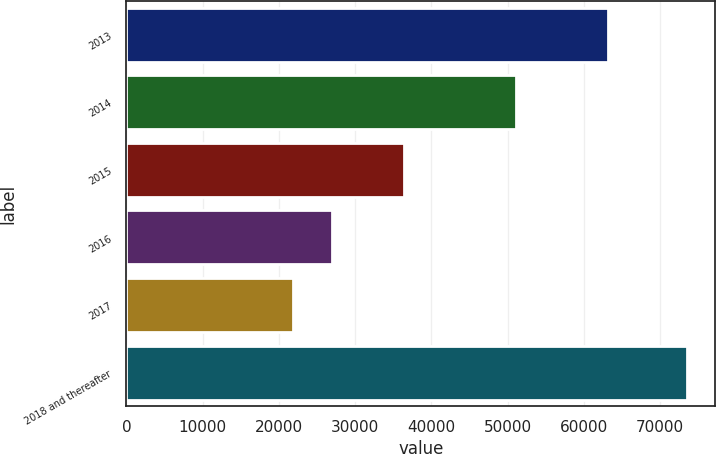Convert chart to OTSL. <chart><loc_0><loc_0><loc_500><loc_500><bar_chart><fcel>2013<fcel>2014<fcel>2015<fcel>2016<fcel>2017<fcel>2018 and thereafter<nl><fcel>63228<fcel>51064<fcel>36470<fcel>27007<fcel>21837<fcel>73537<nl></chart> 